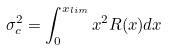Convert formula to latex. <formula><loc_0><loc_0><loc_500><loc_500>\sigma _ { c } ^ { 2 } = \int _ { 0 } ^ { x _ { l i m } } x ^ { 2 } R ( x ) d x</formula> 